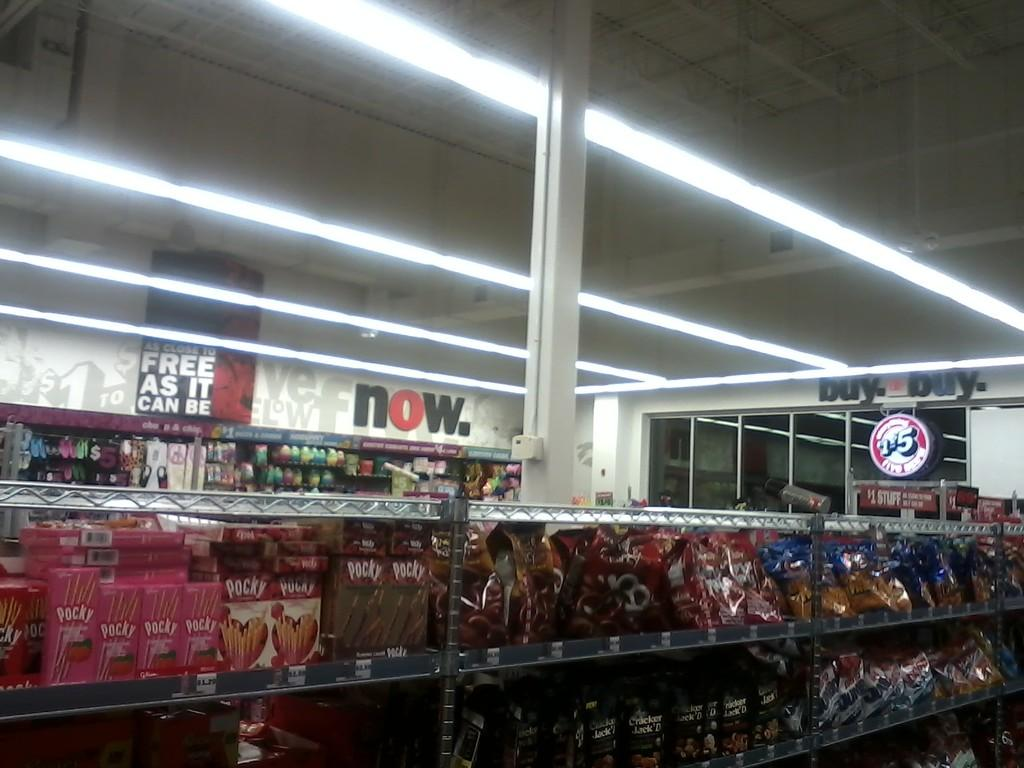<image>
Summarize the visual content of the image. the word now that is on the wall in a store 